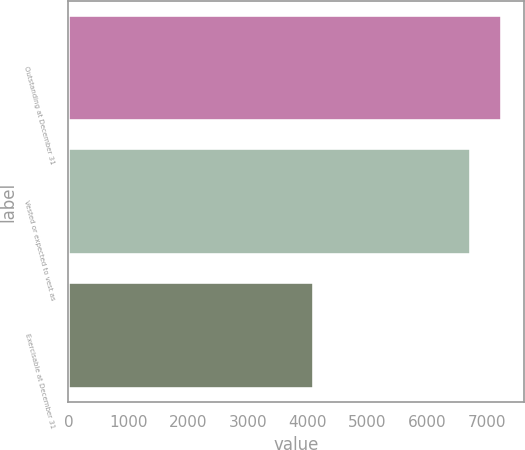Convert chart. <chart><loc_0><loc_0><loc_500><loc_500><bar_chart><fcel>Outstanding at December 31<fcel>Vested or expected to vest as<fcel>Exercisable at December 31<nl><fcel>7257<fcel>6742<fcel>4107<nl></chart> 